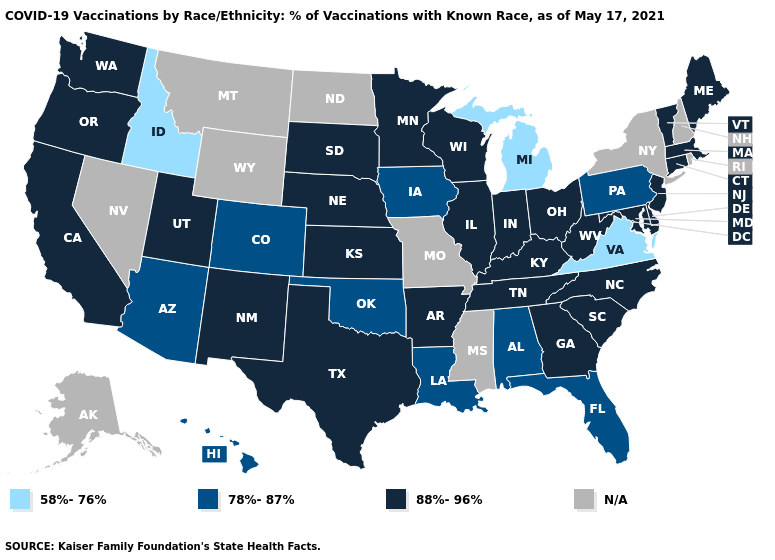Which states have the lowest value in the MidWest?
Quick response, please. Michigan. Name the states that have a value in the range 58%-76%?
Keep it brief. Idaho, Michigan, Virginia. What is the lowest value in the Northeast?
Answer briefly. 78%-87%. Name the states that have a value in the range 88%-96%?
Short answer required. Arkansas, California, Connecticut, Delaware, Georgia, Illinois, Indiana, Kansas, Kentucky, Maine, Maryland, Massachusetts, Minnesota, Nebraska, New Jersey, New Mexico, North Carolina, Ohio, Oregon, South Carolina, South Dakota, Tennessee, Texas, Utah, Vermont, Washington, West Virginia, Wisconsin. Among the states that border California , which have the lowest value?
Answer briefly. Arizona. What is the value of Alaska?
Concise answer only. N/A. Does the map have missing data?
Concise answer only. Yes. What is the value of Nebraska?
Keep it brief. 88%-96%. Does the first symbol in the legend represent the smallest category?
Short answer required. Yes. What is the lowest value in states that border Nebraska?
Keep it brief. 78%-87%. Does Michigan have the lowest value in the MidWest?
Be succinct. Yes. What is the lowest value in the USA?
Be succinct. 58%-76%. Which states have the lowest value in the USA?
Quick response, please. Idaho, Michigan, Virginia. What is the value of Kansas?
Keep it brief. 88%-96%. What is the value of South Carolina?
Be succinct. 88%-96%. 